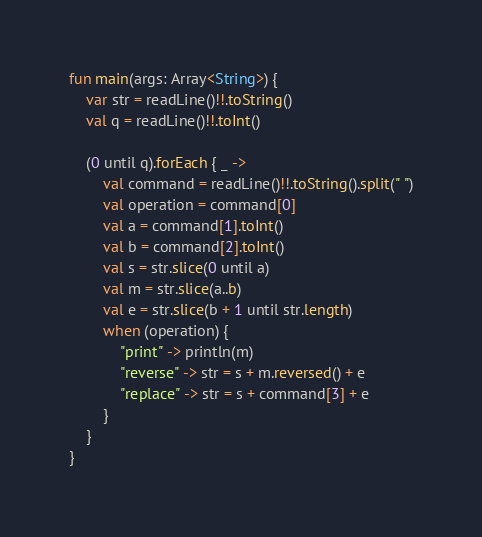Convert code to text. <code><loc_0><loc_0><loc_500><loc_500><_Kotlin_>fun main(args: Array<String>) {
    var str = readLine()!!.toString()
    val q = readLine()!!.toInt()

    (0 until q).forEach { _ ->
        val command = readLine()!!.toString().split(" ")
        val operation = command[0]
        val a = command[1].toInt()
        val b = command[2].toInt()
        val s = str.slice(0 until a)
        val m = str.slice(a..b)
        val e = str.slice(b + 1 until str.length)
        when (operation) {
            "print" -> println(m)
            "reverse" -> str = s + m.reversed() + e
            "replace" -> str = s + command[3] + e
        }
    }
}
</code> 